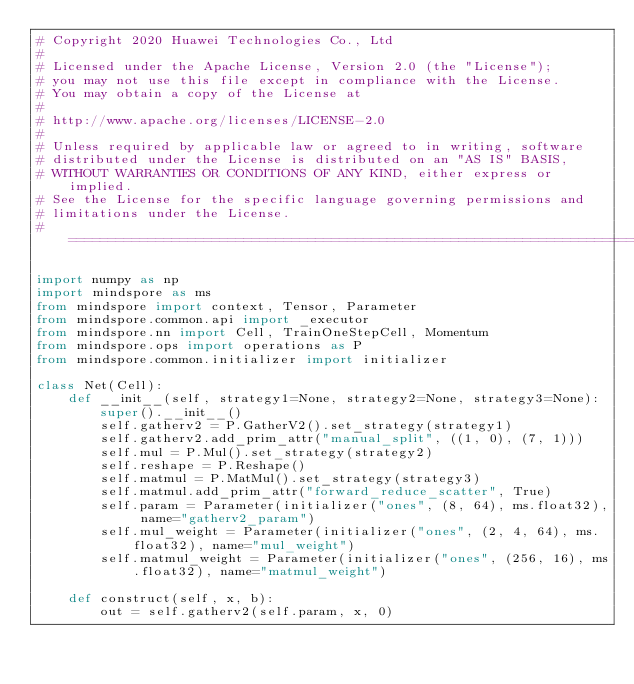Convert code to text. <code><loc_0><loc_0><loc_500><loc_500><_Python_># Copyright 2020 Huawei Technologies Co., Ltd
#
# Licensed under the Apache License, Version 2.0 (the "License");
# you may not use this file except in compliance with the License.
# You may obtain a copy of the License at
#
# http://www.apache.org/licenses/LICENSE-2.0
#
# Unless required by applicable law or agreed to in writing, software
# distributed under the License is distributed on an "AS IS" BASIS,
# WITHOUT WARRANTIES OR CONDITIONS OF ANY KIND, either express or implied.
# See the License for the specific language governing permissions and
# limitations under the License.
# ============================================================================

import numpy as np
import mindspore as ms
from mindspore import context, Tensor, Parameter
from mindspore.common.api import _executor
from mindspore.nn import Cell, TrainOneStepCell, Momentum
from mindspore.ops import operations as P
from mindspore.common.initializer import initializer

class Net(Cell):
    def __init__(self, strategy1=None, strategy2=None, strategy3=None):
        super().__init__()
        self.gatherv2 = P.GatherV2().set_strategy(strategy1)
        self.gatherv2.add_prim_attr("manual_split", ((1, 0), (7, 1)))
        self.mul = P.Mul().set_strategy(strategy2)
        self.reshape = P.Reshape()
        self.matmul = P.MatMul().set_strategy(strategy3)
        self.matmul.add_prim_attr("forward_reduce_scatter", True)
        self.param = Parameter(initializer("ones", (8, 64), ms.float32), name="gatherv2_param")
        self.mul_weight = Parameter(initializer("ones", (2, 4, 64), ms.float32), name="mul_weight")
        self.matmul_weight = Parameter(initializer("ones", (256, 16), ms.float32), name="matmul_weight")

    def construct(self, x, b):
        out = self.gatherv2(self.param, x, 0)</code> 